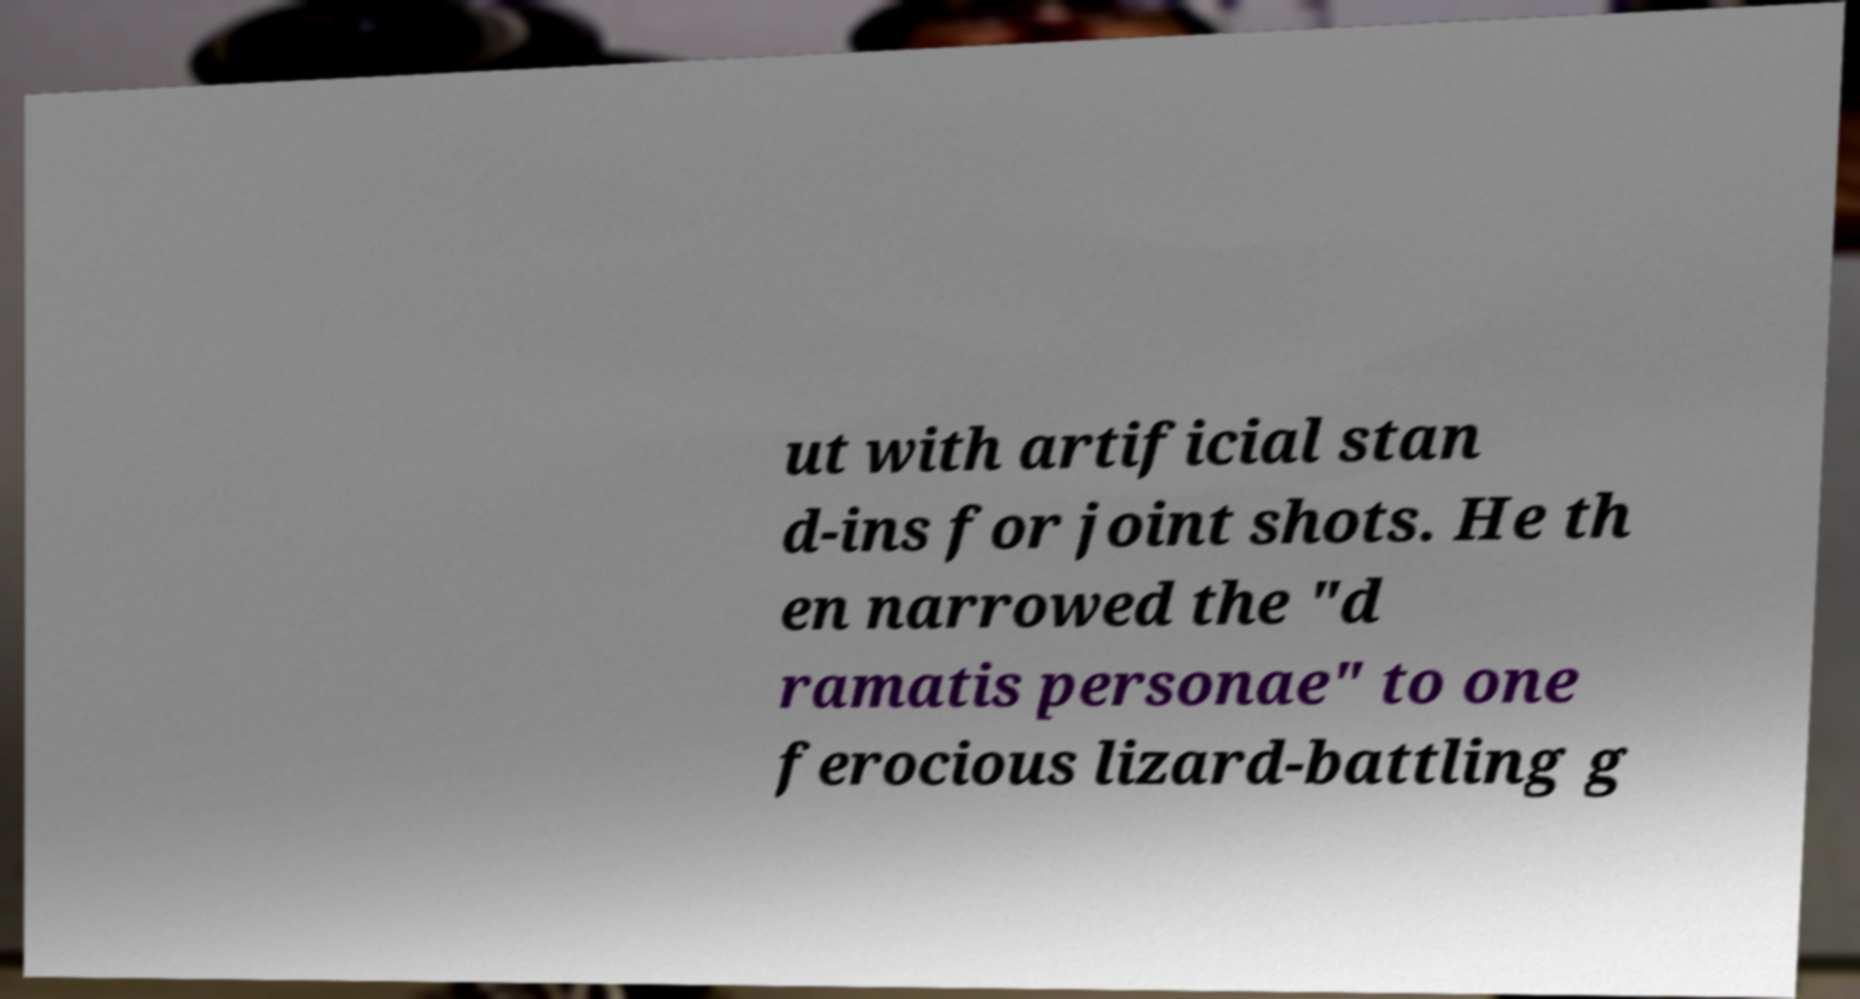Could you assist in decoding the text presented in this image and type it out clearly? ut with artificial stan d-ins for joint shots. He th en narrowed the "d ramatis personae" to one ferocious lizard-battling g 